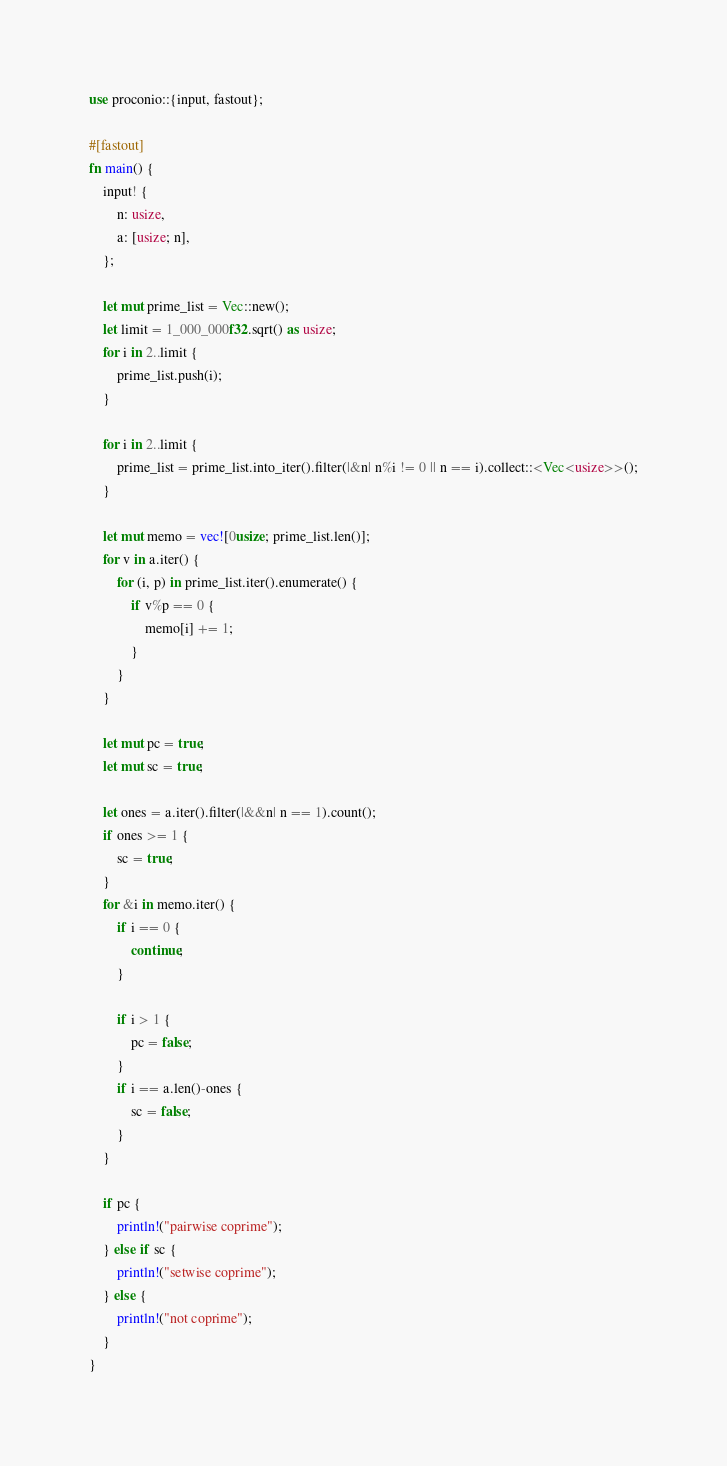Convert code to text. <code><loc_0><loc_0><loc_500><loc_500><_Rust_>use proconio::{input, fastout};

#[fastout]
fn main() {
    input! {
        n: usize,
        a: [usize; n],
    };

    let mut prime_list = Vec::new();
    let limit = 1_000_000f32.sqrt() as usize;
    for i in 2..limit {
        prime_list.push(i);
    }

    for i in 2..limit {
        prime_list = prime_list.into_iter().filter(|&n| n%i != 0 || n == i).collect::<Vec<usize>>();
    }

    let mut memo = vec![0usize; prime_list.len()];
    for v in a.iter() {
        for (i, p) in prime_list.iter().enumerate() {
            if v%p == 0 {
                memo[i] += 1;
            }
        }
    }

    let mut pc = true;
    let mut sc = true;
    
    let ones = a.iter().filter(|&&n| n == 1).count();
    if ones >= 1 {
        sc = true;
    }
    for &i in memo.iter() {
        if i == 0 {
            continue;
        }

        if i > 1 {
            pc = false;
        }
        if i == a.len()-ones {
            sc = false;
        }
    }

    if pc {
        println!("pairwise coprime");
    } else if sc {
        println!("setwise coprime");
    } else {
        println!("not coprime");
    }
}
</code> 